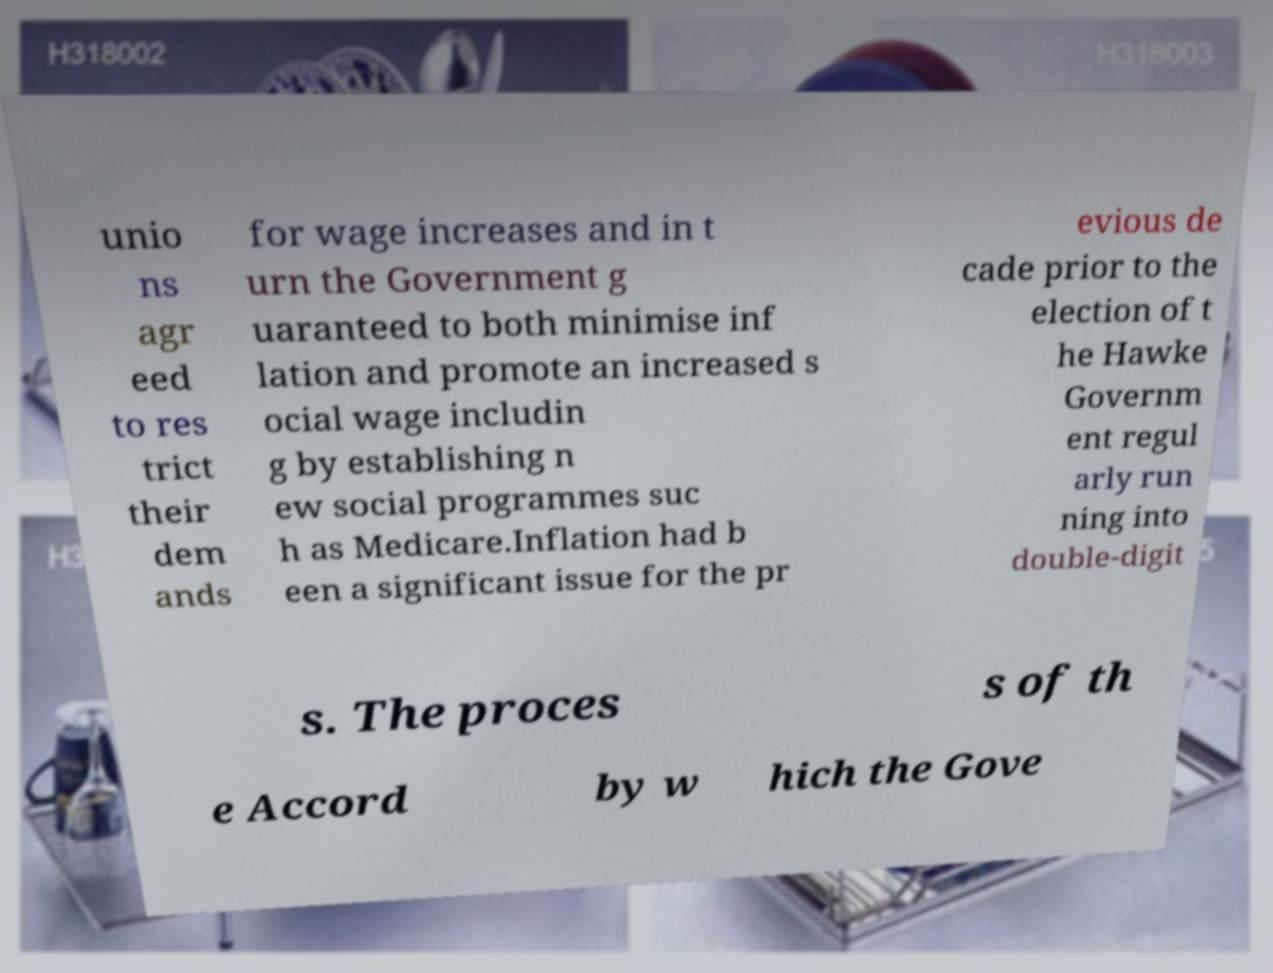There's text embedded in this image that I need extracted. Can you transcribe it verbatim? unio ns agr eed to res trict their dem ands for wage increases and in t urn the Government g uaranteed to both minimise inf lation and promote an increased s ocial wage includin g by establishing n ew social programmes suc h as Medicare.Inflation had b een a significant issue for the pr evious de cade prior to the election of t he Hawke Governm ent regul arly run ning into double-digit s. The proces s of th e Accord by w hich the Gove 